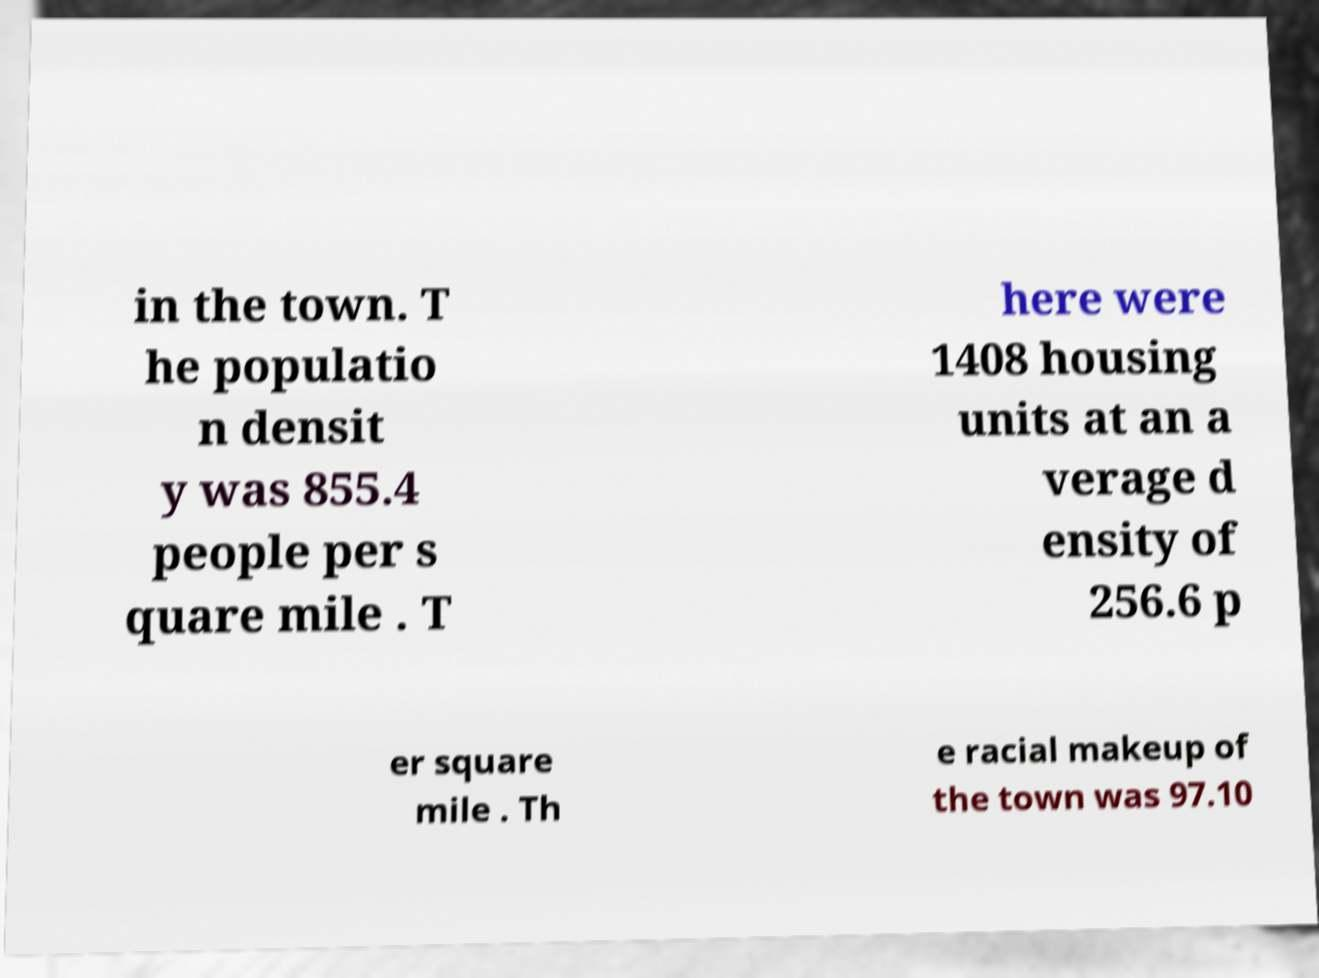Please identify and transcribe the text found in this image. in the town. T he populatio n densit y was 855.4 people per s quare mile . T here were 1408 housing units at an a verage d ensity of 256.6 p er square mile . Th e racial makeup of the town was 97.10 